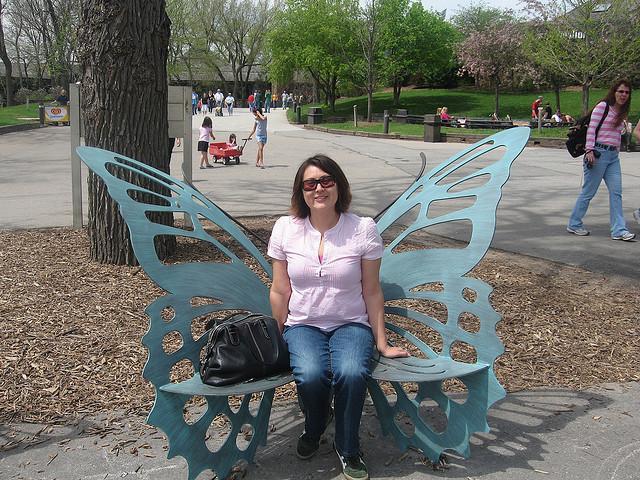What is the process that produces the type of animal depicted on the bench called?
Select the accurate answer and provide explanation: 'Answer: answer
Rationale: rationale.'
Options: Germination, pollination, metamorphosis, mitosis. Answer: metamorphosis.
Rationale: A caterpillar will turn into this. 